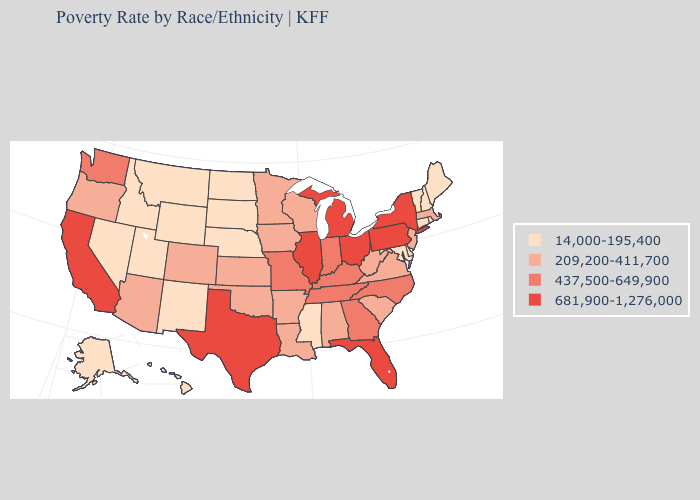What is the lowest value in states that border Louisiana?
Quick response, please. 14,000-195,400. Name the states that have a value in the range 209,200-411,700?
Be succinct. Alabama, Arizona, Arkansas, Colorado, Iowa, Kansas, Louisiana, Massachusetts, Minnesota, New Jersey, Oklahoma, Oregon, South Carolina, Virginia, West Virginia, Wisconsin. How many symbols are there in the legend?
Be succinct. 4. Among the states that border Iowa , does Nebraska have the lowest value?
Quick response, please. Yes. Does Maryland have the lowest value in the USA?
Write a very short answer. Yes. Does the map have missing data?
Give a very brief answer. No. Among the states that border Wyoming , which have the highest value?
Quick response, please. Colorado. Name the states that have a value in the range 209,200-411,700?
Be succinct. Alabama, Arizona, Arkansas, Colorado, Iowa, Kansas, Louisiana, Massachusetts, Minnesota, New Jersey, Oklahoma, Oregon, South Carolina, Virginia, West Virginia, Wisconsin. What is the lowest value in the USA?
Be succinct. 14,000-195,400. Name the states that have a value in the range 437,500-649,900?
Quick response, please. Georgia, Indiana, Kentucky, Missouri, North Carolina, Tennessee, Washington. What is the value of New York?
Short answer required. 681,900-1,276,000. Which states have the lowest value in the USA?
Write a very short answer. Alaska, Connecticut, Delaware, Hawaii, Idaho, Maine, Maryland, Mississippi, Montana, Nebraska, Nevada, New Hampshire, New Mexico, North Dakota, Rhode Island, South Dakota, Utah, Vermont, Wyoming. Which states have the highest value in the USA?
Keep it brief. California, Florida, Illinois, Michigan, New York, Ohio, Pennsylvania, Texas. What is the value of Alaska?
Short answer required. 14,000-195,400. What is the highest value in states that border Arizona?
Short answer required. 681,900-1,276,000. 